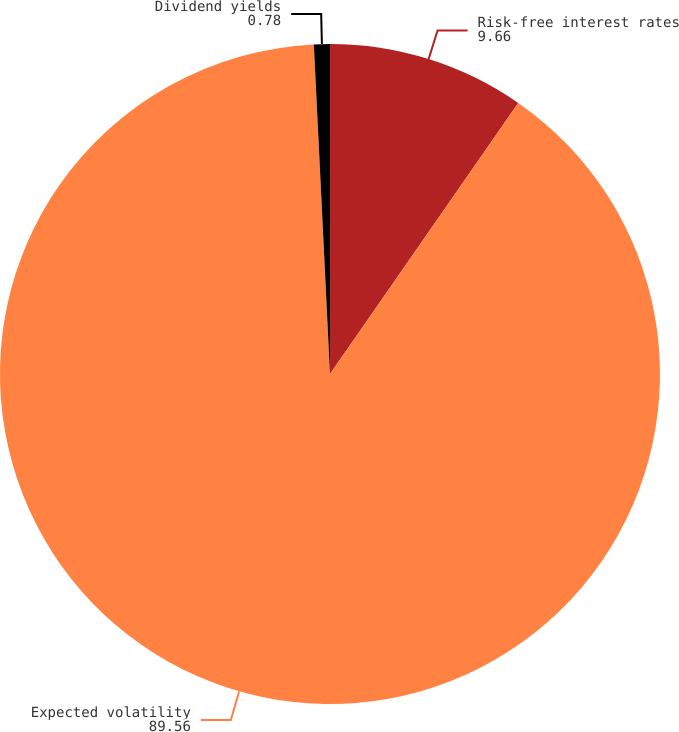Convert chart to OTSL. <chart><loc_0><loc_0><loc_500><loc_500><pie_chart><fcel>Risk-free interest rates<fcel>Expected volatility<fcel>Dividend yields<nl><fcel>9.66%<fcel>89.56%<fcel>0.78%<nl></chart> 